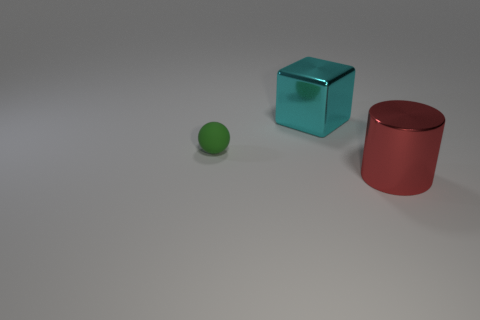Add 2 metal balls. How many objects exist? 5 Subtract 1 cyan cubes. How many objects are left? 2 Subtract all balls. How many objects are left? 2 Subtract all cyan objects. Subtract all red metallic cylinders. How many objects are left? 1 Add 3 metallic objects. How many metallic objects are left? 5 Add 1 tiny rubber balls. How many tiny rubber balls exist? 2 